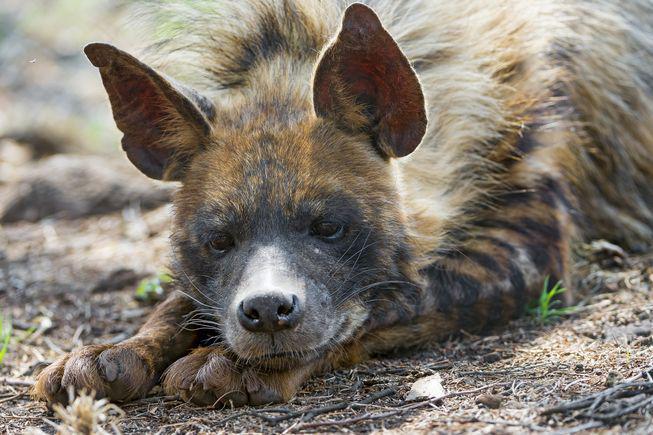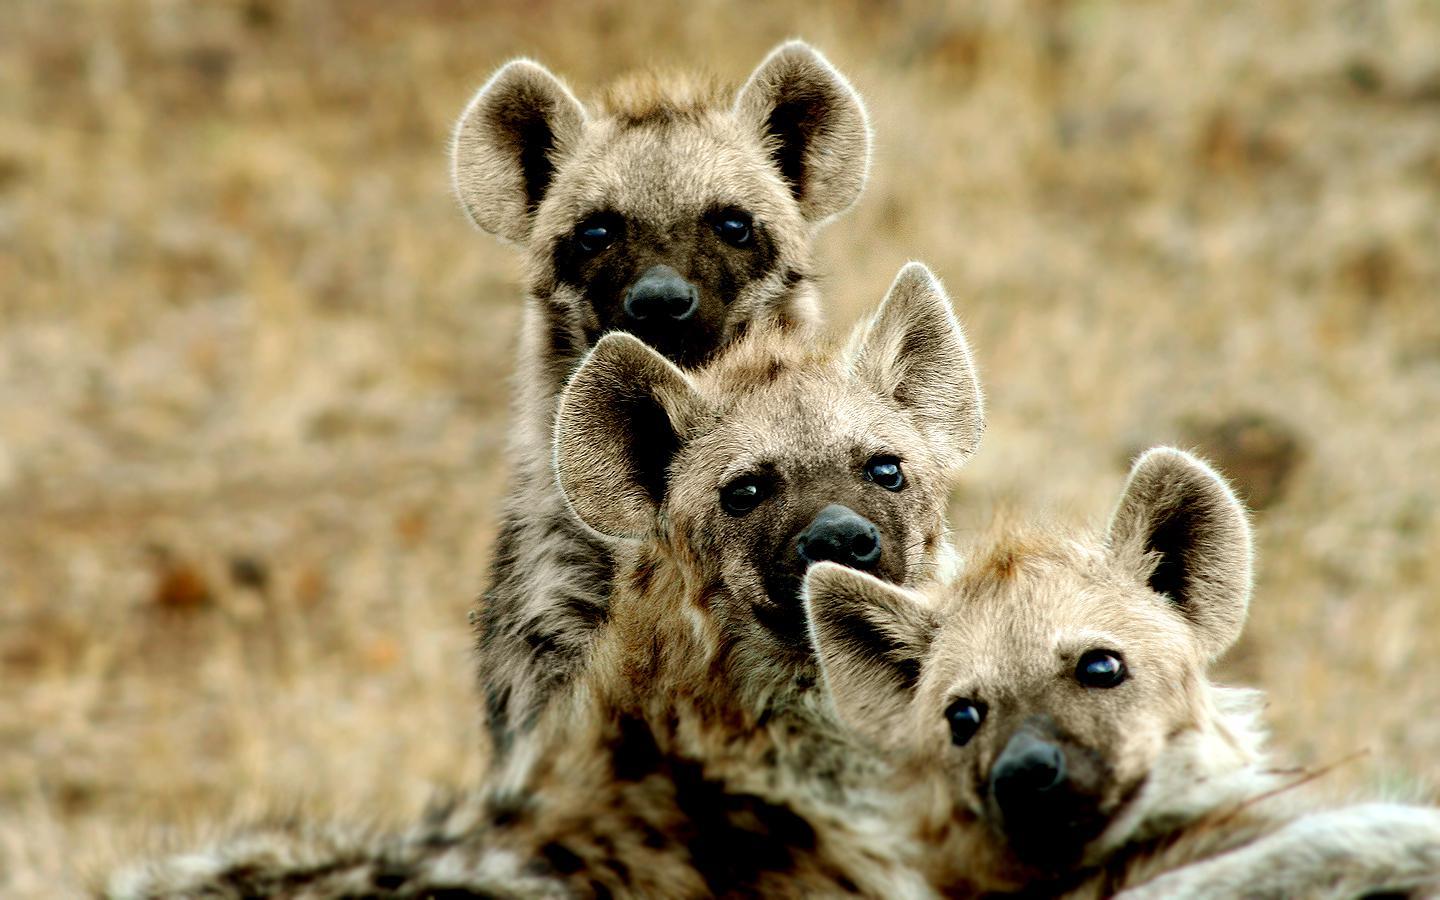The first image is the image on the left, the second image is the image on the right. Given the left and right images, does the statement "Neither image in the pair shows a hyena with it's mouth opened and teeth exposed." hold true? Answer yes or no. Yes. The first image is the image on the left, the second image is the image on the right. Considering the images on both sides, is "The left and right image contains the same number of hyenas." valid? Answer yes or no. No. 